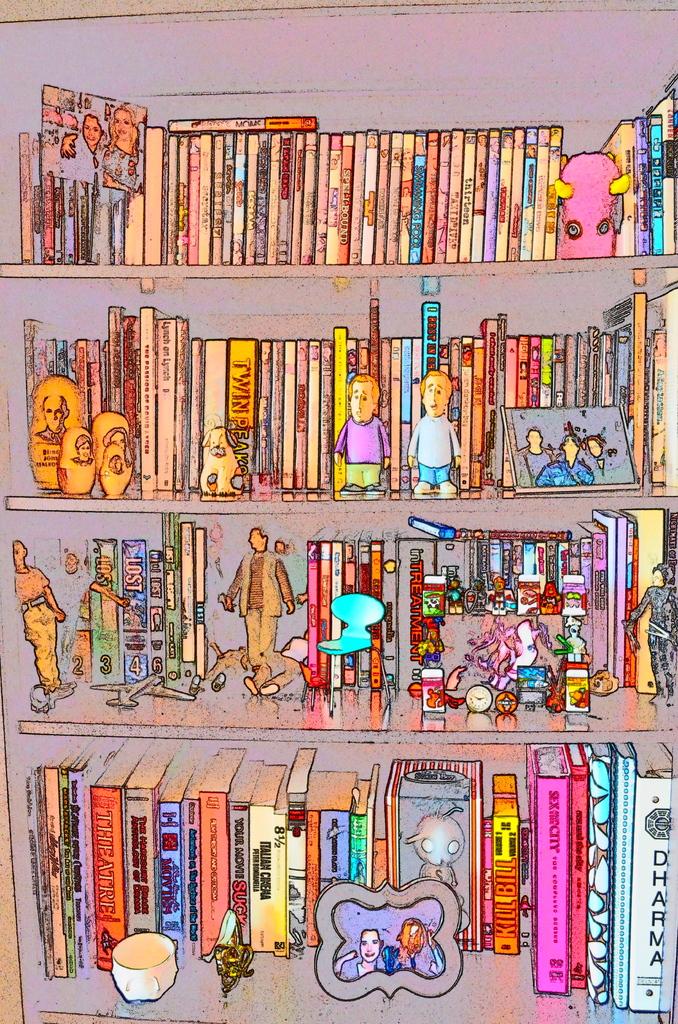The lowest book on the right side has what written on its binding?
Your response must be concise. Dharma. 